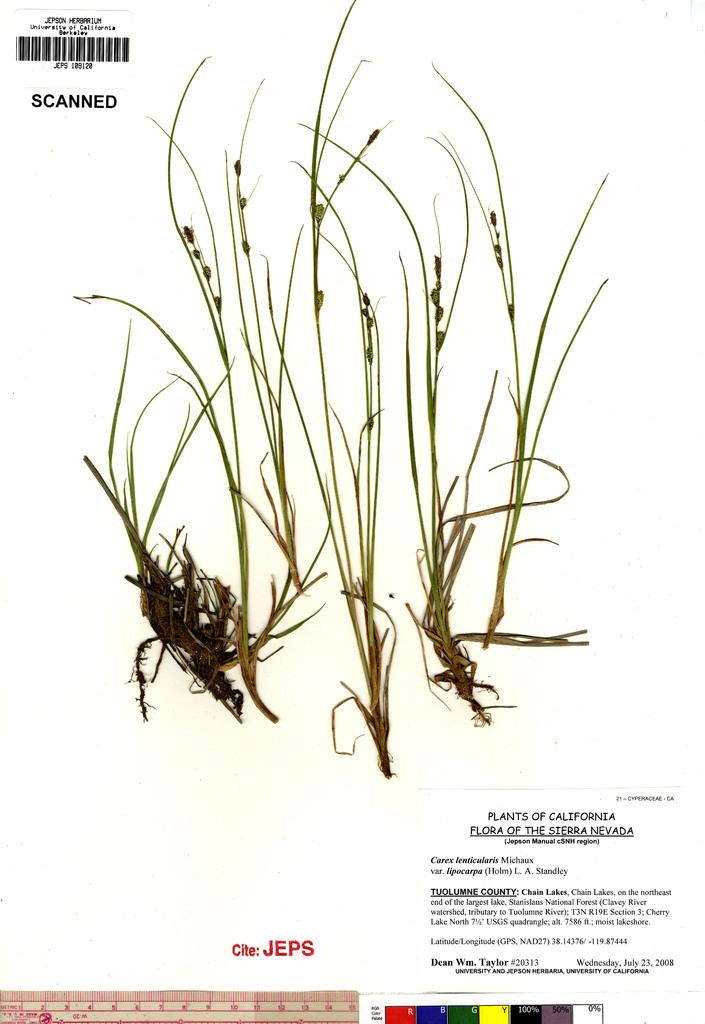What is depicted on the poster in the image? There is a poster of plants in the image. What additional feature can be seen on the poster? There is a bar code on the poster. What type of information is provided on the poster? The poster contains information about plants. What type of insurance is advertised on the poster? There is no insurance advertised on the poster; it contains information about plants. Can you see an arm holding the poster in the image? There is no arm or person holding the poster in the image; it is displayed on its own. 